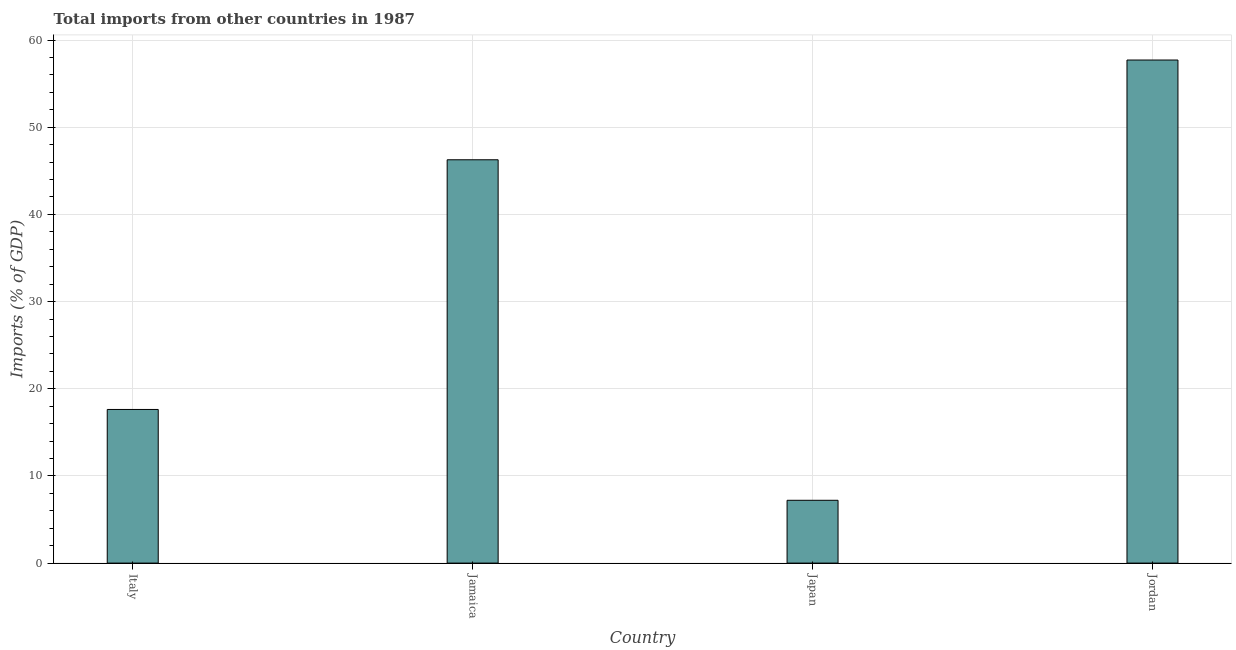Does the graph contain grids?
Offer a terse response. Yes. What is the title of the graph?
Keep it short and to the point. Total imports from other countries in 1987. What is the label or title of the Y-axis?
Keep it short and to the point. Imports (% of GDP). What is the total imports in Jordan?
Provide a short and direct response. 57.71. Across all countries, what is the maximum total imports?
Offer a terse response. 57.71. Across all countries, what is the minimum total imports?
Offer a very short reply. 7.21. In which country was the total imports maximum?
Keep it short and to the point. Jordan. In which country was the total imports minimum?
Ensure brevity in your answer.  Japan. What is the sum of the total imports?
Give a very brief answer. 128.81. What is the difference between the total imports in Italy and Japan?
Offer a terse response. 10.42. What is the average total imports per country?
Offer a terse response. 32.2. What is the median total imports?
Provide a short and direct response. 31.95. In how many countries, is the total imports greater than 38 %?
Provide a succinct answer. 2. What is the ratio of the total imports in Italy to that in Jordan?
Your answer should be compact. 0.3. Is the total imports in Japan less than that in Jordan?
Keep it short and to the point. Yes. What is the difference between the highest and the second highest total imports?
Offer a very short reply. 11.44. Is the sum of the total imports in Italy and Japan greater than the maximum total imports across all countries?
Your answer should be very brief. No. What is the difference between the highest and the lowest total imports?
Ensure brevity in your answer.  50.5. In how many countries, is the total imports greater than the average total imports taken over all countries?
Give a very brief answer. 2. Are all the bars in the graph horizontal?
Make the answer very short. No. How many countries are there in the graph?
Make the answer very short. 4. What is the difference between two consecutive major ticks on the Y-axis?
Ensure brevity in your answer.  10. What is the Imports (% of GDP) in Italy?
Provide a succinct answer. 17.63. What is the Imports (% of GDP) of Jamaica?
Offer a terse response. 46.27. What is the Imports (% of GDP) of Japan?
Offer a very short reply. 7.21. What is the Imports (% of GDP) in Jordan?
Provide a succinct answer. 57.71. What is the difference between the Imports (% of GDP) in Italy and Jamaica?
Offer a very short reply. -28.64. What is the difference between the Imports (% of GDP) in Italy and Japan?
Provide a short and direct response. 10.42. What is the difference between the Imports (% of GDP) in Italy and Jordan?
Keep it short and to the point. -40.09. What is the difference between the Imports (% of GDP) in Jamaica and Japan?
Provide a short and direct response. 39.06. What is the difference between the Imports (% of GDP) in Jamaica and Jordan?
Offer a terse response. -11.44. What is the difference between the Imports (% of GDP) in Japan and Jordan?
Give a very brief answer. -50.5. What is the ratio of the Imports (% of GDP) in Italy to that in Jamaica?
Ensure brevity in your answer.  0.38. What is the ratio of the Imports (% of GDP) in Italy to that in Japan?
Make the answer very short. 2.45. What is the ratio of the Imports (% of GDP) in Italy to that in Jordan?
Give a very brief answer. 0.3. What is the ratio of the Imports (% of GDP) in Jamaica to that in Japan?
Your response must be concise. 6.42. What is the ratio of the Imports (% of GDP) in Jamaica to that in Jordan?
Your answer should be compact. 0.8. 